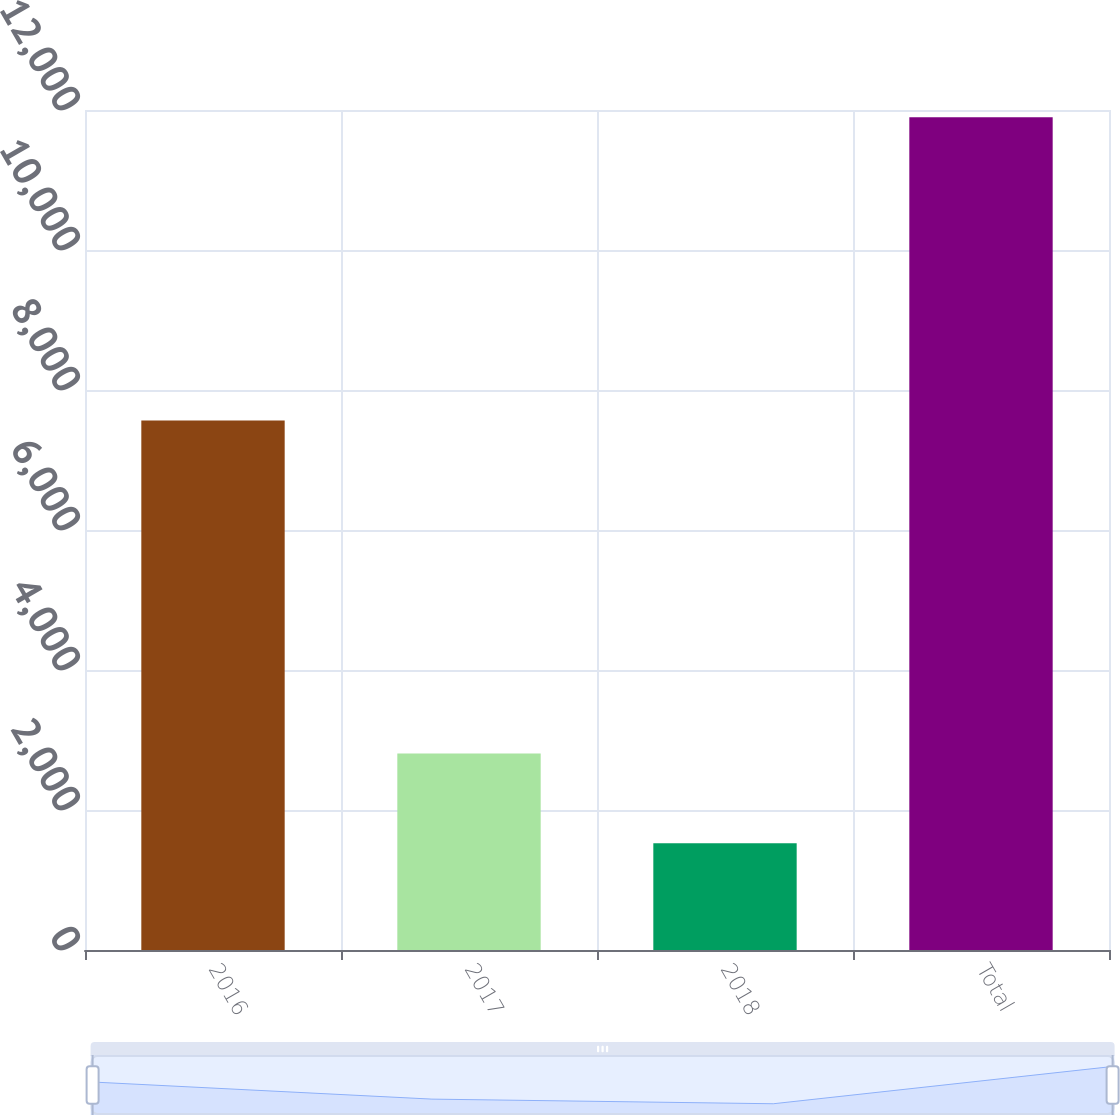Convert chart. <chart><loc_0><loc_0><loc_500><loc_500><bar_chart><fcel>2016<fcel>2017<fcel>2018<fcel>Total<nl><fcel>7564<fcel>2806<fcel>1525<fcel>11895<nl></chart> 